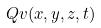Convert formula to latex. <formula><loc_0><loc_0><loc_500><loc_500>Q v ( x , y , z , t )</formula> 